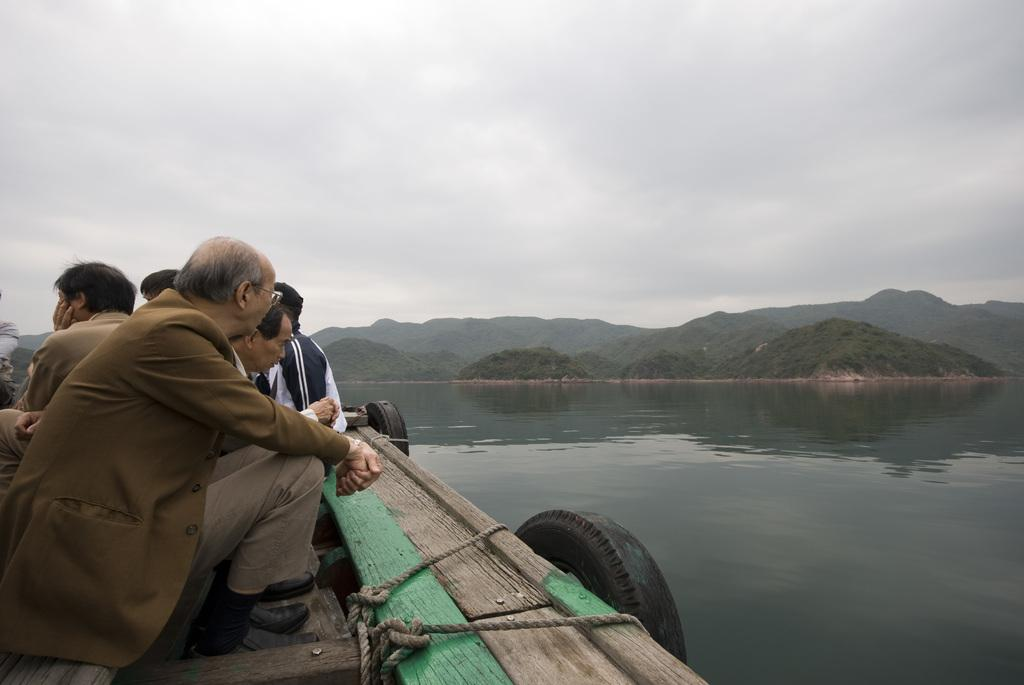How many people are in the group visible in the image? There is a group of people in the image, but the exact number cannot be determined from the provided facts. What objects can be seen in the image besides the people? There are tyres, water, mountains, a tree, and ropes visible in the image. What is visible in the background of the image? In the background of the image, there is water, mountains, a tree, and the sky. What might be used for tying or securing in the image? Ropes are present in the image, which might be used for tying or securing. What type of organization is hosting the party in the image? There is no party or organization present in the image; it features a group of people, tyres, water, mountains, a tree, ropes, and the sky. Who are the friends of the people in the image? The provided facts do not mention any friends or relationships between the people in the image. 